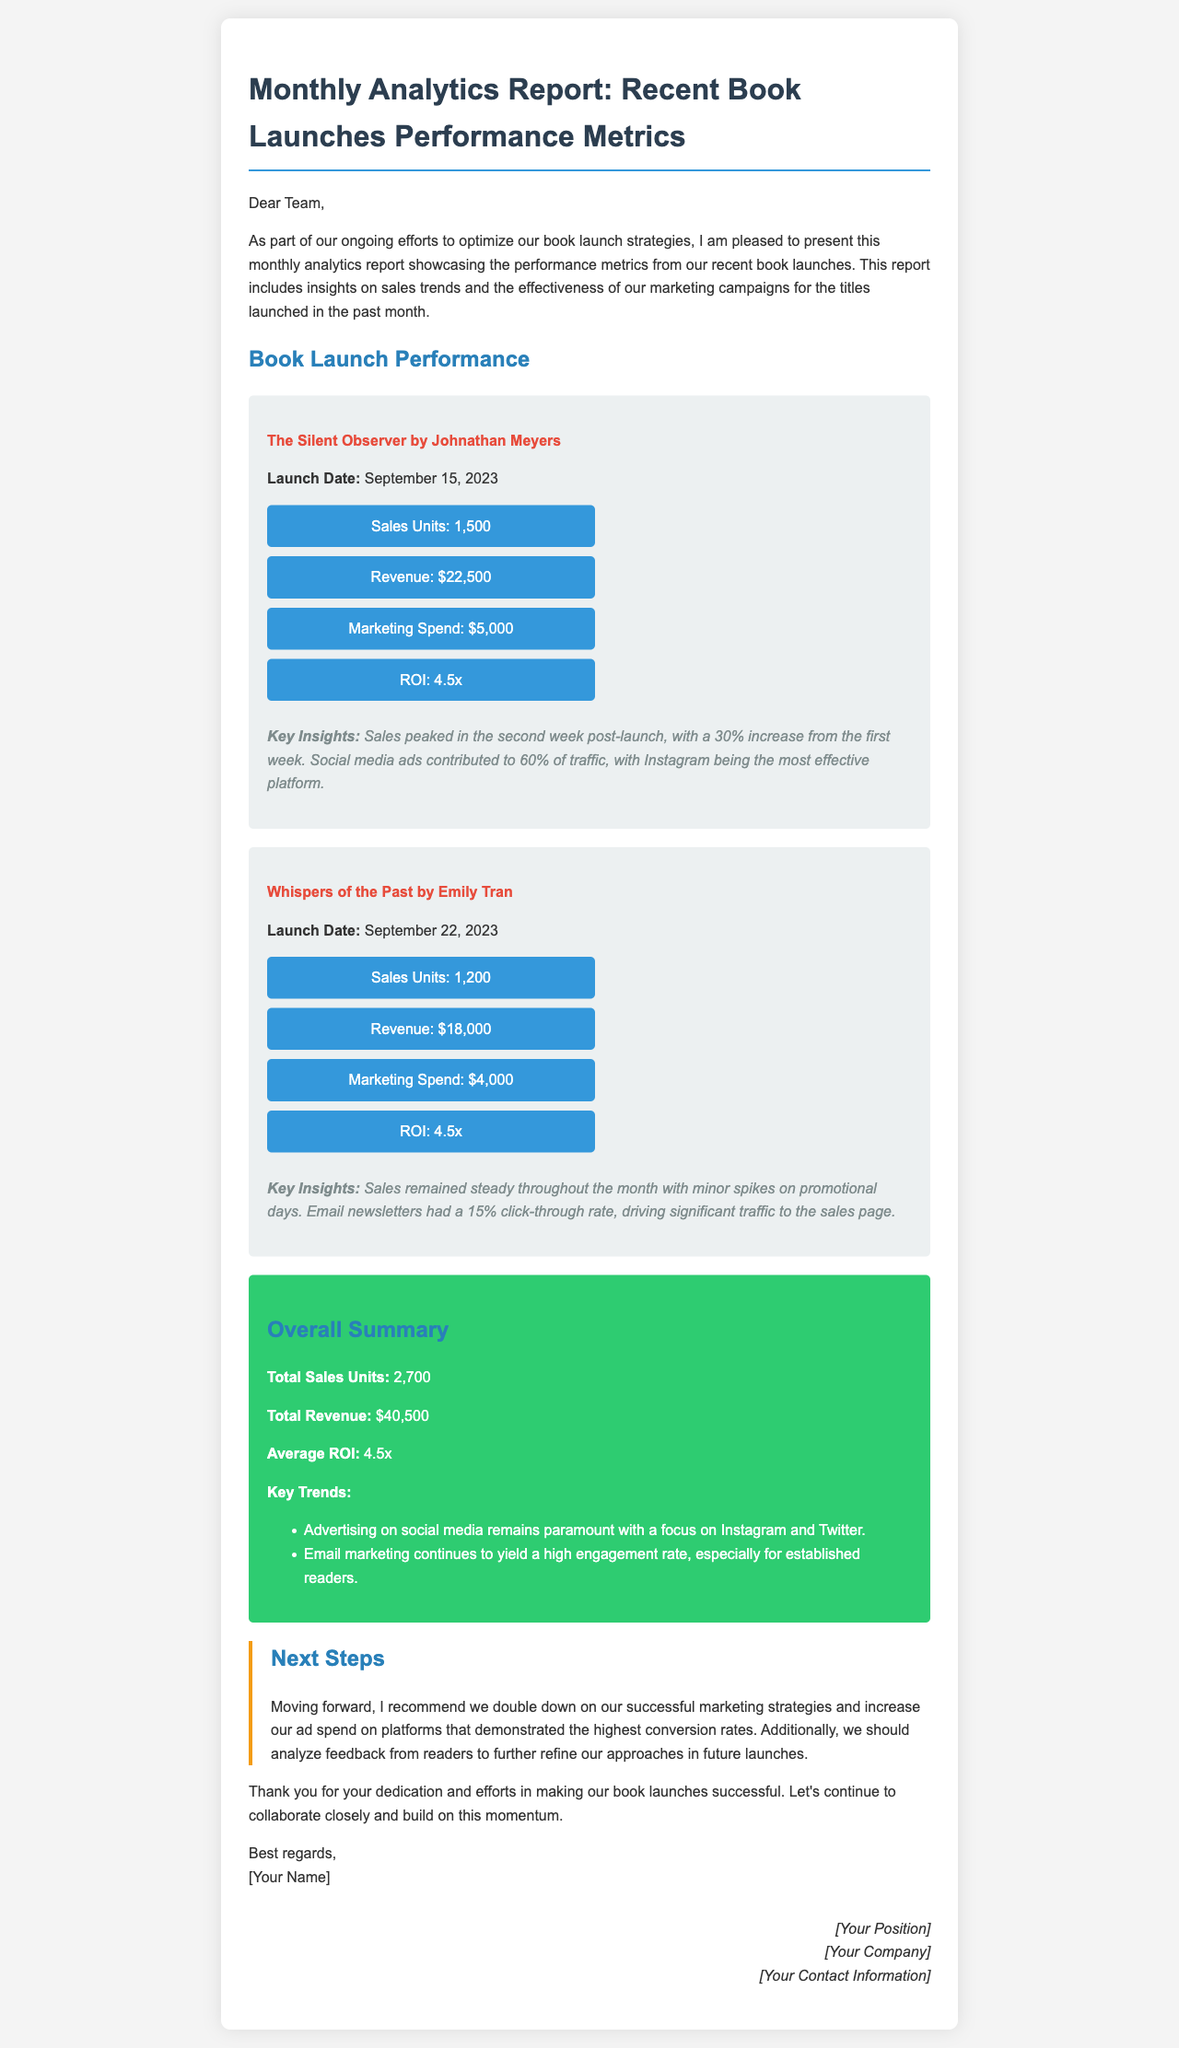What are the launch dates of the books? The document provides the launch dates for both books: "The Silent Observer" was launched on September 15, 2023, and "Whispers of the Past" was launched on September 22, 2023.
Answer: September 15, 2023; September 22, 2023 What is the total revenue? The total revenue is calculated by adding the revenue from both book launches: $22,500 + $18,000 = $40,500.
Answer: $40,500 What was the ROI for both books? The document states the ROI for both books is the same: 4.5x for both "The Silent Observer" and "Whispers of the Past."
Answer: 4.5x Which marketing method generated the most traffic for "The Silent Observer"? The insights indicate that social media ads contributed to 60% of the traffic, with Instagram being the most effective platform.
Answer: Instagram How many sales units were achieved for "Whispers of the Past"? The document specifies that "Whispers of the Past" achieved sales of 1,200 units.
Answer: 1,200 What is the average ROI for the book launches? The average ROI calculated from both launches is stated as 4.5x in the overall summary.
Answer: 4.5x What recommendations are made for future marketing strategies? The document suggests doubling down on successful marketing strategies and increasing ad spend on high-conversion platforms.
Answer: Increase ad spend on high-conversion platforms What is the click-through rate for the email newsletters mentioned? The email newsletters had a reported click-through rate of 15%, as stated in the insights for "Whispers of the Past."
Answer: 15% What is the main color used for the title section in the document? The document uses a blue color (#2c3e50) for the main title section.
Answer: Blue 